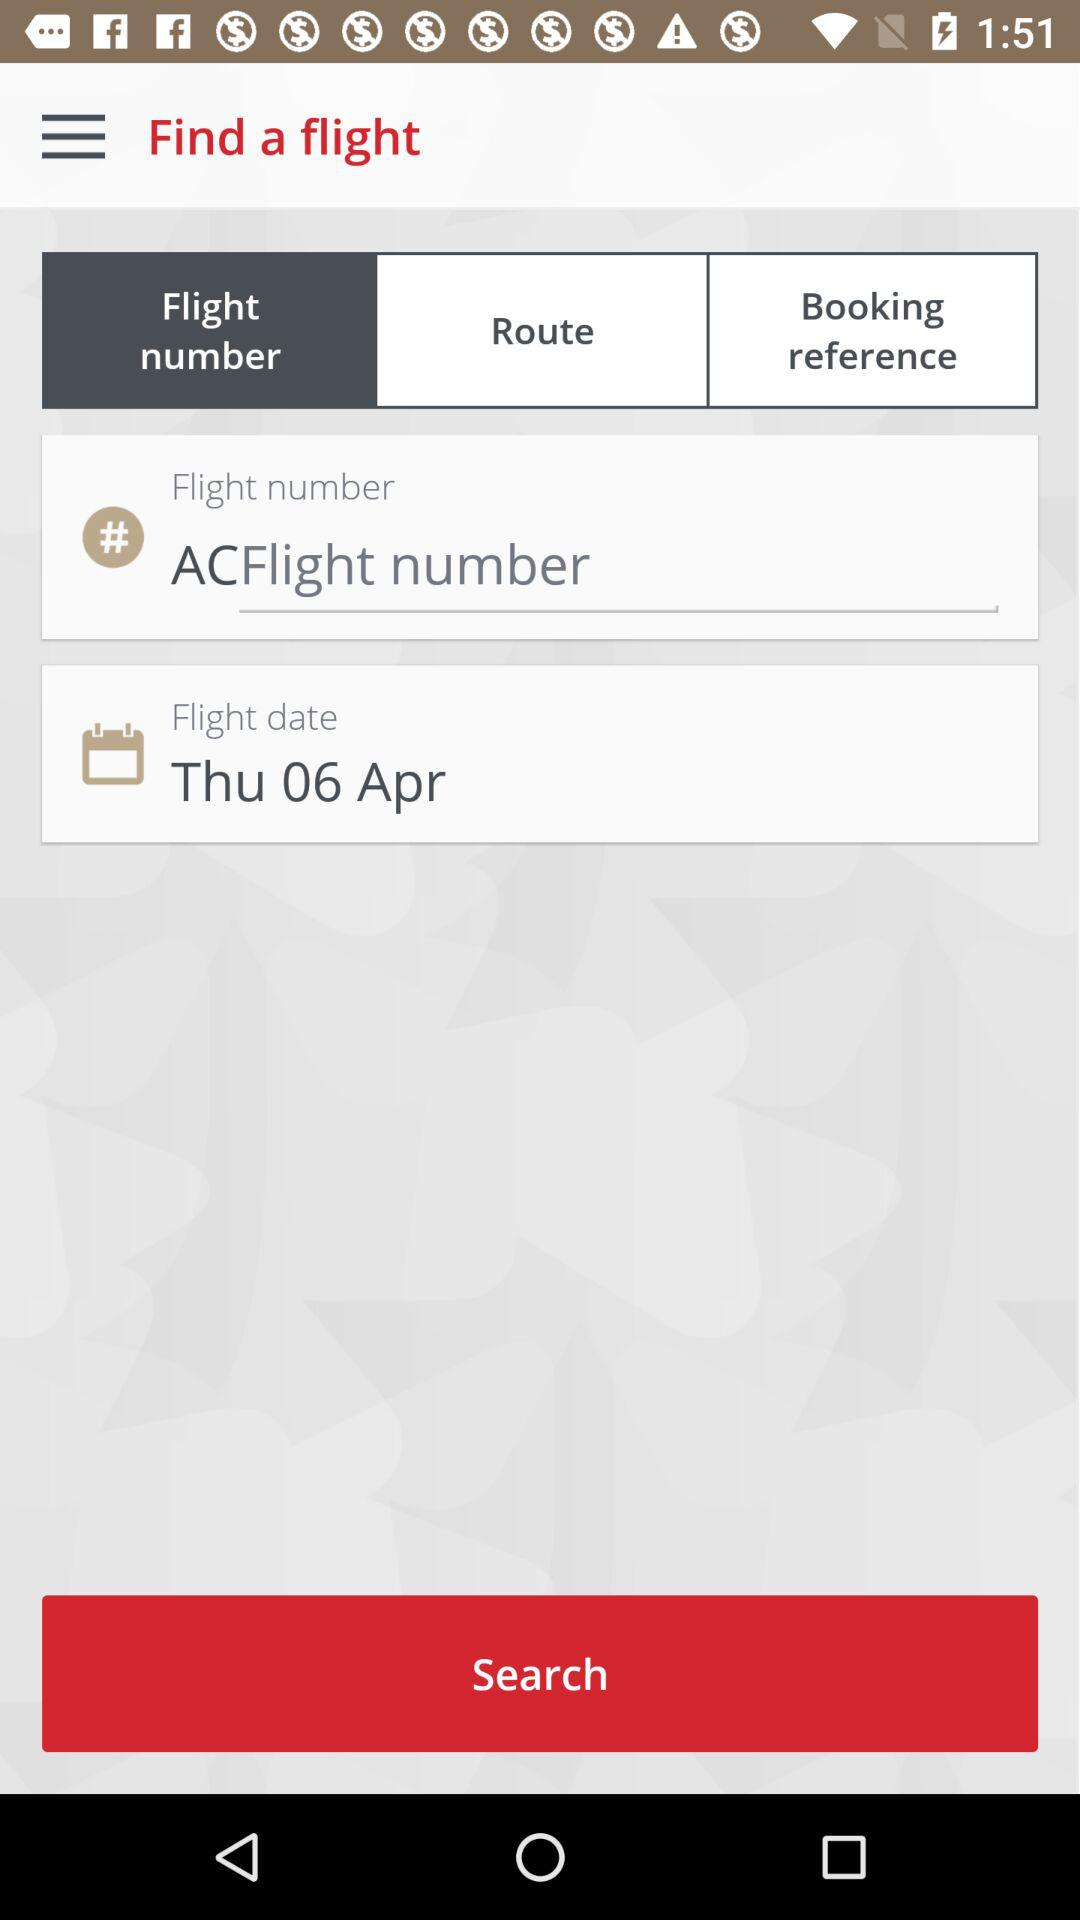How many input fields are required to search for a flight? To search for a flight, you would typically need to fill out at least three to four input fields, including the departure and arrival locations, the departure date, and possibly the return date if it's a round trip. Additional options might include class of service, number of passengers, and specific airline preference. In the image displayed, there are fields for the flight number, route, booking reference, and flight date, indicating at least four primary pieces of information are requested to proceed with the search. 